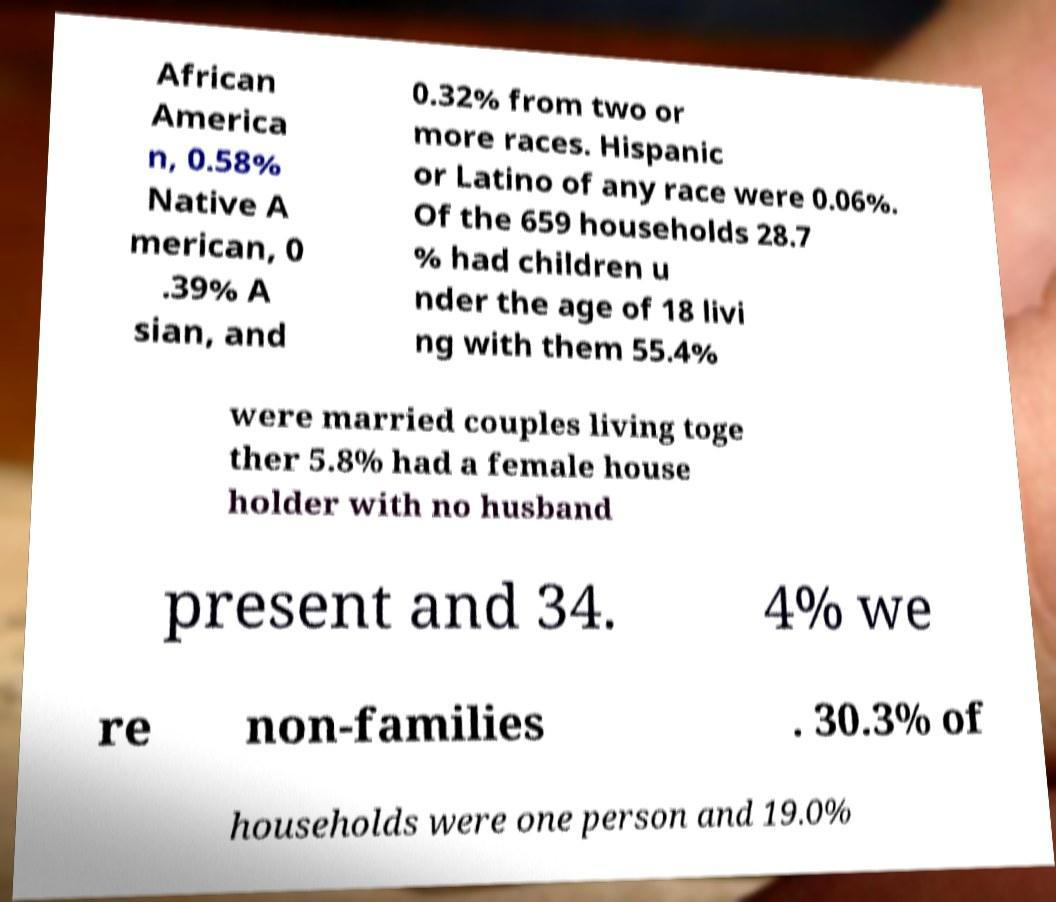Please identify and transcribe the text found in this image. African America n, 0.58% Native A merican, 0 .39% A sian, and 0.32% from two or more races. Hispanic or Latino of any race were 0.06%. Of the 659 households 28.7 % had children u nder the age of 18 livi ng with them 55.4% were married couples living toge ther 5.8% had a female house holder with no husband present and 34. 4% we re non-families . 30.3% of households were one person and 19.0% 